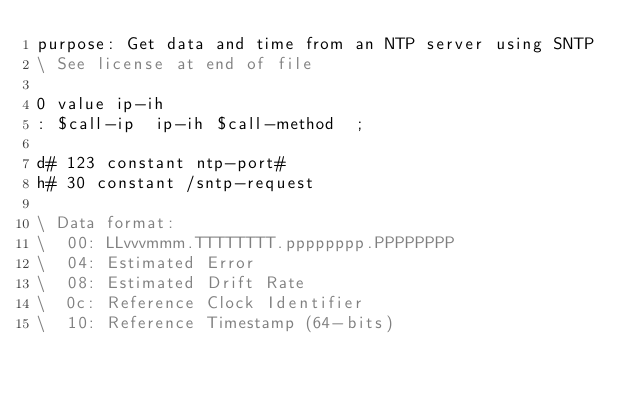<code> <loc_0><loc_0><loc_500><loc_500><_Forth_>purpose: Get data and time from an NTP server using SNTP
\ See license at end of file

0 value ip-ih
: $call-ip  ip-ih $call-method  ;

d# 123 constant ntp-port#
h# 30 constant /sntp-request

\ Data format:
\  00: LLvvvmmm.TTTTTTTT.pppppppp.PPPPPPPP
\  04: Estimated Error
\  08: Estimated Drift Rate
\  0c: Reference Clock Identifier
\  10: Reference Timestamp (64-bits)</code> 